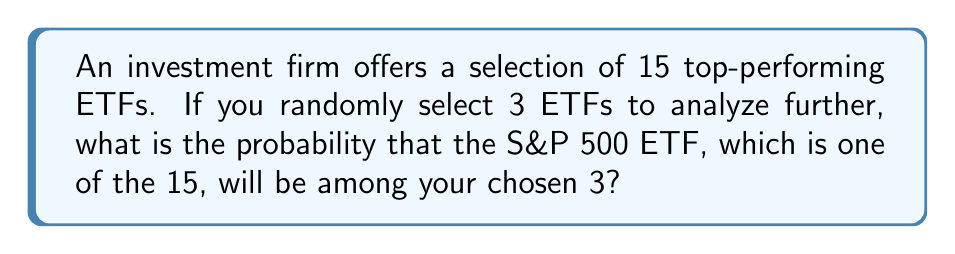What is the answer to this math problem? Let's approach this step-by-step:

1) This is a combination problem. We need to calculate the probability of selecting the S&P 500 ETF along with 2 other ETFs out of the remaining 14.

2) Total number of ways to select 3 ETFs out of 15:
   $$\binom{15}{3} = \frac{15!}{3!(15-3)!} = \frac{15!}{3!12!} = 455$$

3) Number of ways to select the S&P 500 ETF and 2 others:
   - The S&P 500 ETF is already selected (1 way)
   - We need to select 2 more out of the remaining 14:
     $$\binom{14}{2} = \frac{14!}{2!(14-2)!} = \frac{14!}{2!12!} = 91$$

4) Probability = (Favorable outcomes) / (Total outcomes)
   $$P(\text{S&P 500 ETF selected}) = \frac{91}{455} = \frac{1}{5} = 0.2$$

Therefore, the probability of selecting the S&P 500 ETF when randomly choosing 3 out of 15 ETFs is 0.2 or 20%.
Answer: $\frac{1}{5}$ or 0.2 or 20% 